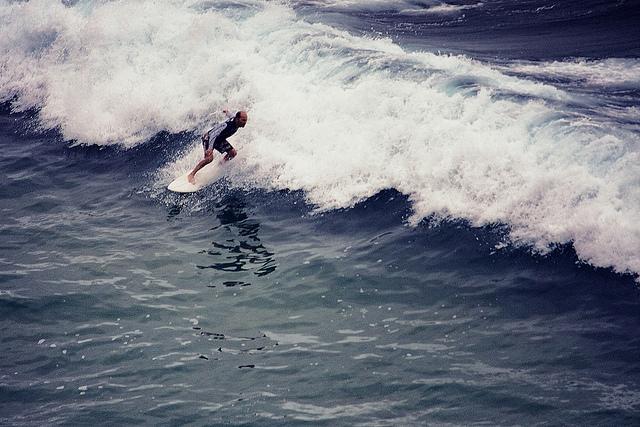What color is the surfboard?
Be succinct. White. Is the guy higher than the waves?
Answer briefly. No. Is the man riding a snowboard?
Short answer required. No. How many people are in this photo?
Write a very short answer. 1. What time of day was this picture taken?
Write a very short answer. Afternoon. Did this person fall off the board?
Answer briefly. No. Where was this picture taken?
Be succinct. Ocean. Is the surfer facing to or away from the wave?
Keep it brief. Away. What sport is being depicted?
Quick response, please. Surfing. Is the man facing the waves?
Answer briefly. Yes. 